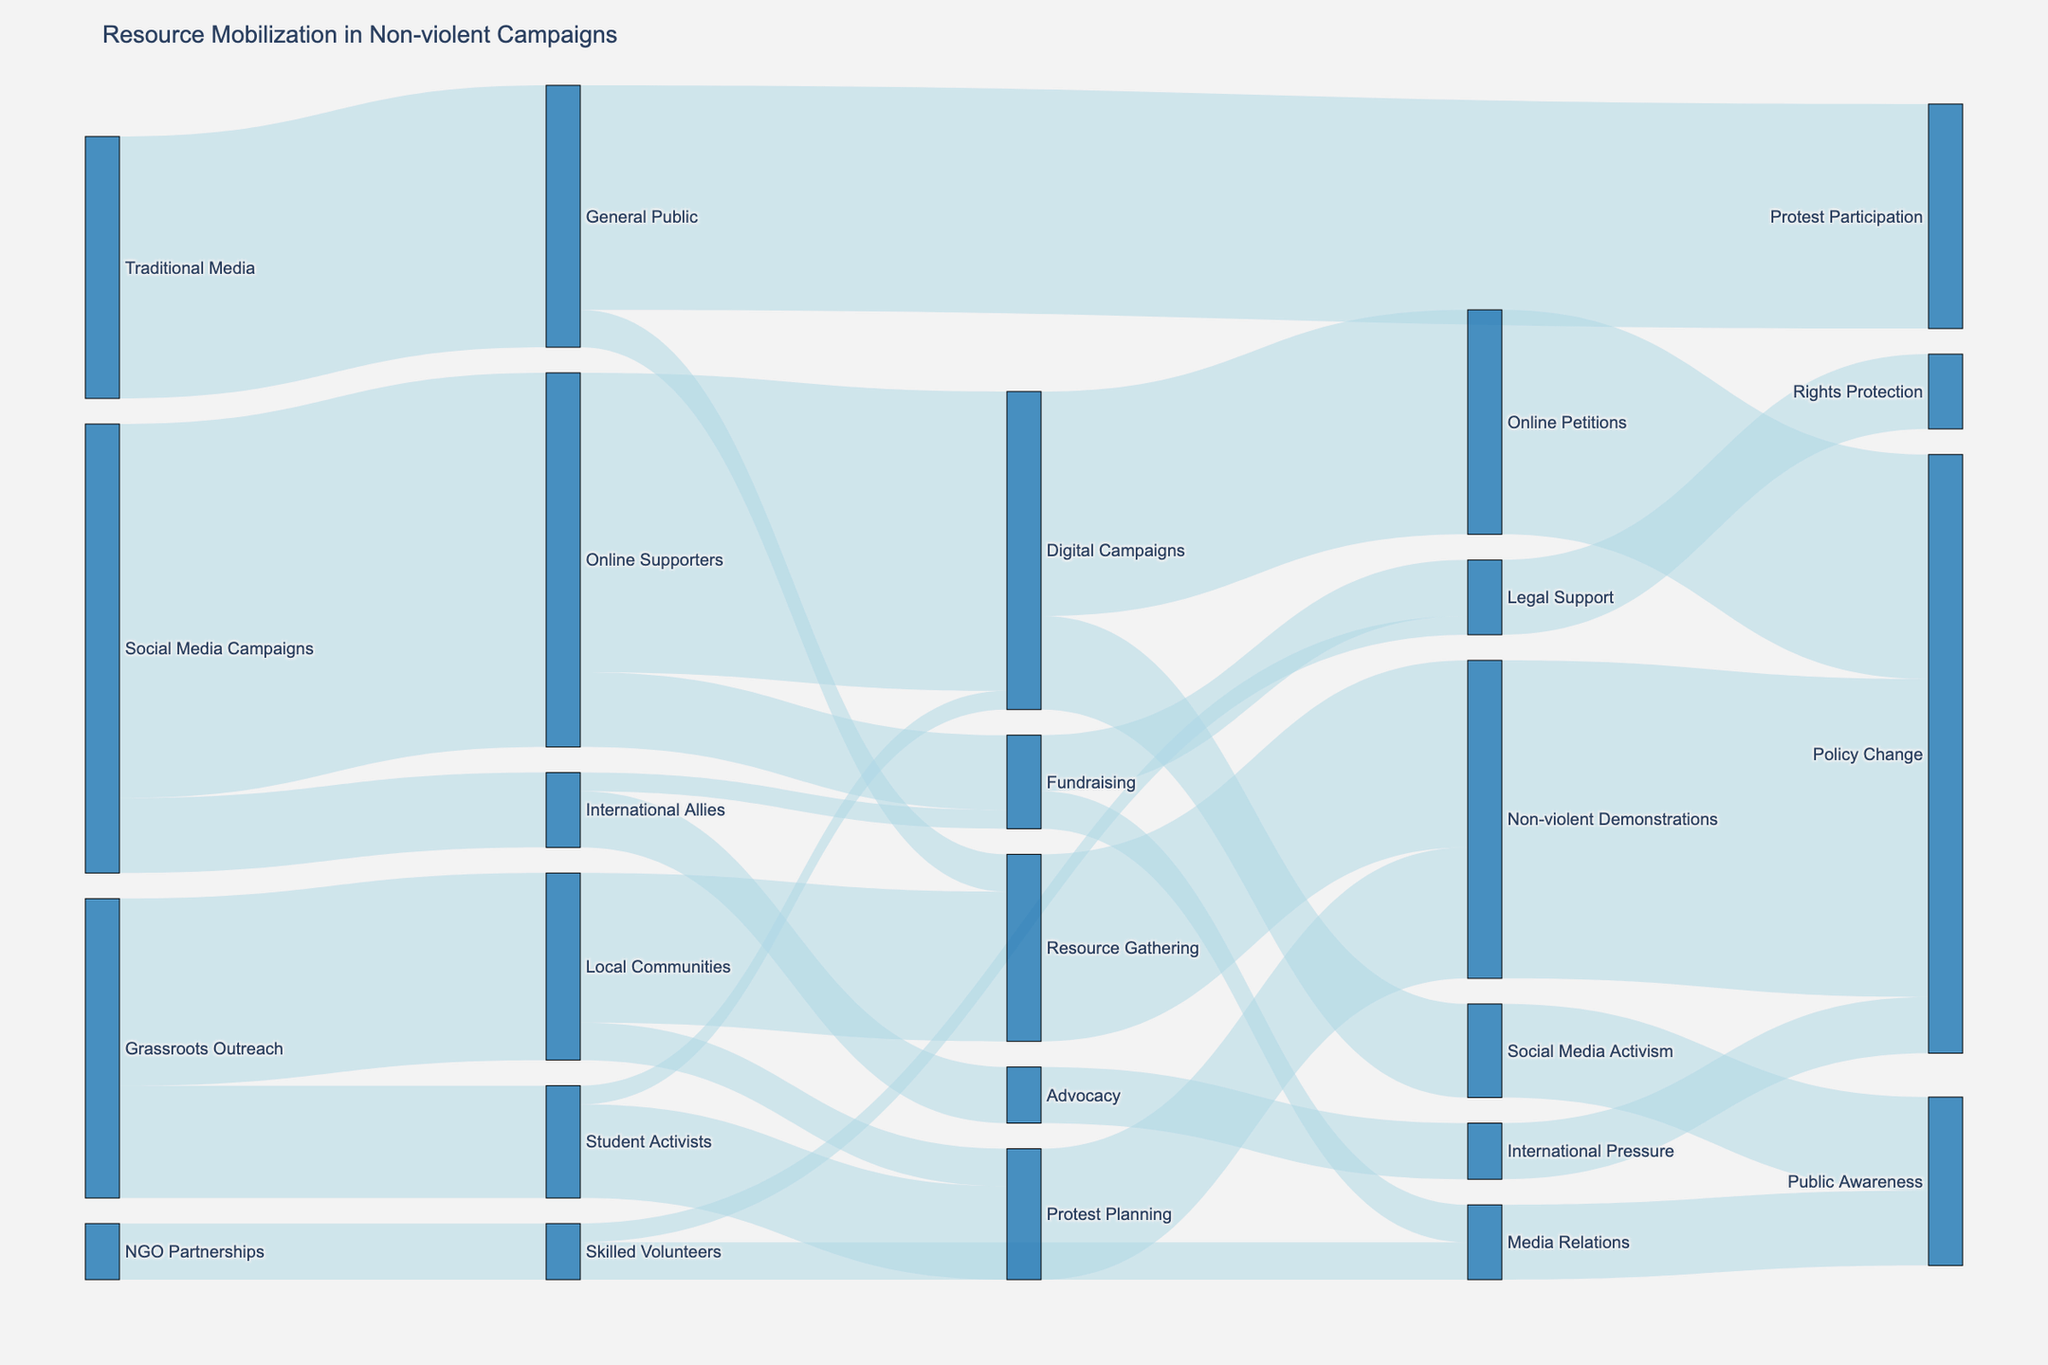What resources were mobilized the most through Social Media Campaigns? From the diagram, Social Media Campaigns connect to Online Supporters and International Allies. The value flowing to Online Supporters is 10,000, and to International Allies is 2,000. The larger resource mobilized through Social Media Campaigns is to Online Supporters.
Answer: Online Supporters How many total resources were mobilized from Grassroots Outreach? Summing the values from Grassroots Outreach to Student Activists (3,000) and Local Communities (5,000) gives 8,000.
Answer: 8,000 Which group contributes the most to Non-violent Demonstrations? Checking the diagram, Non-violent Demonstrations receive values from Protest Planning (3,500) and Resource Gathering (5,000). The largest contribution is from Resource Gathering.
Answer: Resource Gathering Is there a group that contributes to both Fundraising and Digital Campaigns? The diagram shows that Online Supporters contribute to both Digital Campaigns (8,000) and Fundraising (2,000).
Answer: Online Supporters Through what path does the General Public directly contribute to Policy Change? Following the connections, the General Public directly contributes to Protest Participation, then Non-violent Demonstrations, and finally Policy Change.
Answer: General Public → Protest Participation → Non-violent Demonstrations → Policy Change What pathway mobilizes resources from International Allies to Policy Change? Starting from International Allies, the resources flow through Advocacy (1,500) to International Pressure and then to Policy Change.
Answer: International Allies → Advocacy → International Pressure → Policy Change Which mobilization source channels the highest value to Policy Change? The inputs to Policy Change are from Non-violent Demonstrations (8,500), Online Petitions (6,000), and International Pressure (1,500). Non-violent Demonstrations channel the highest value.
Answer: Non-violent Demonstrations What's the combined total value from all sources contributing to Media Relations? Adding the values from Skilled Volunteers (1,000) and Fundraising (1,000) gives a total of 2,000.
Answer: 2,000 How does the value mobilized by Local Communities compare to the value mobilized by Student Activists for Protest Planning? The values are 1,000 from Local Communities and 2,500 from Student Activists. Student Activists mobilize more for Protest Planning.
Answer: Student Activists mobilize more How many total resources are mobilized to Legal Support? Adding the values from Skilled Volunteers (500) and Fundraising (1,500) gives a total of 2,000.
Answer: 2,000 